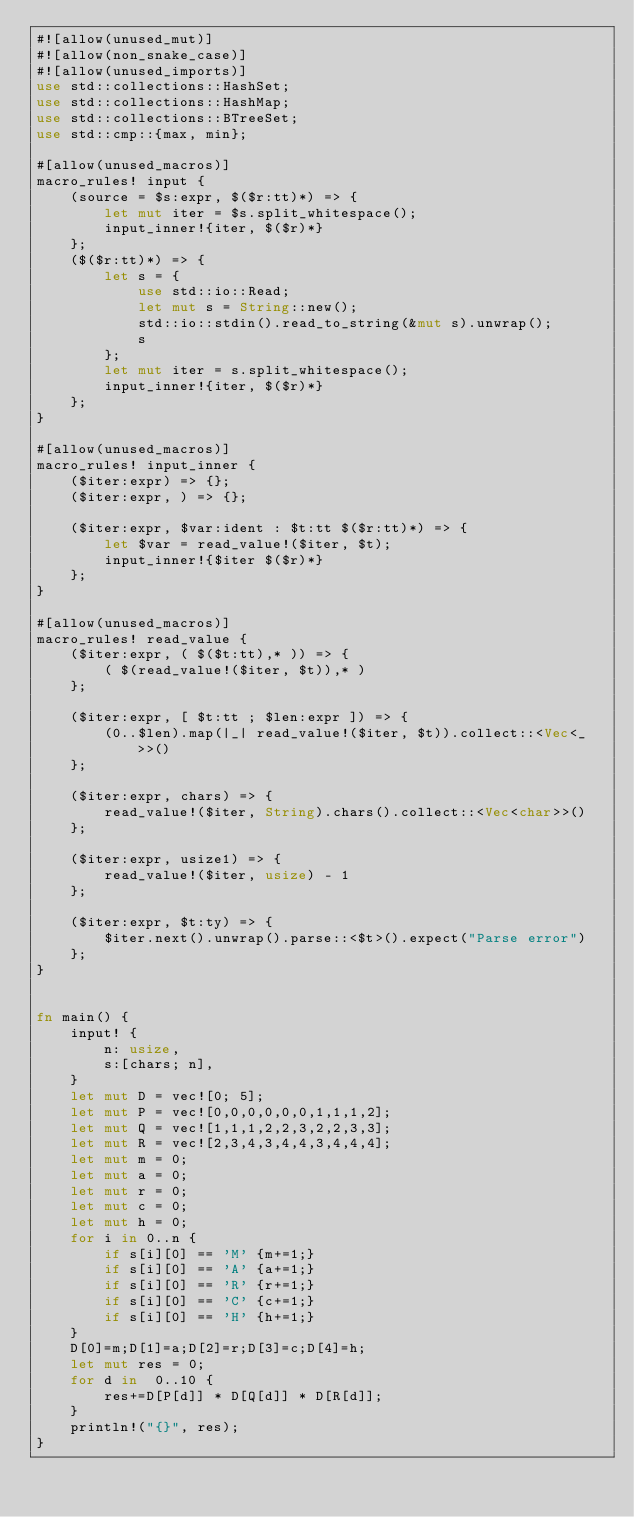<code> <loc_0><loc_0><loc_500><loc_500><_Rust_>#![allow(unused_mut)]
#![allow(non_snake_case)]
#![allow(unused_imports)]
use std::collections::HashSet;
use std::collections::HashMap;
use std::collections::BTreeSet;
use std::cmp::{max, min};

#[allow(unused_macros)]
macro_rules! input {
    (source = $s:expr, $($r:tt)*) => {
        let mut iter = $s.split_whitespace();
        input_inner!{iter, $($r)*}
    };
    ($($r:tt)*) => {
        let s = {
            use std::io::Read;
            let mut s = String::new();
            std::io::stdin().read_to_string(&mut s).unwrap();
            s
        };
        let mut iter = s.split_whitespace();
        input_inner!{iter, $($r)*}
    };
}

#[allow(unused_macros)]
macro_rules! input_inner {
    ($iter:expr) => {};
    ($iter:expr, ) => {};

    ($iter:expr, $var:ident : $t:tt $($r:tt)*) => {
        let $var = read_value!($iter, $t);
        input_inner!{$iter $($r)*}
    };
}

#[allow(unused_macros)]
macro_rules! read_value {
    ($iter:expr, ( $($t:tt),* )) => {
        ( $(read_value!($iter, $t)),* )
    };

    ($iter:expr, [ $t:tt ; $len:expr ]) => {
        (0..$len).map(|_| read_value!($iter, $t)).collect::<Vec<_>>()
    };

    ($iter:expr, chars) => {
        read_value!($iter, String).chars().collect::<Vec<char>>()
    };

    ($iter:expr, usize1) => {
        read_value!($iter, usize) - 1
    };

    ($iter:expr, $t:ty) => {
        $iter.next().unwrap().parse::<$t>().expect("Parse error")
    };
}


fn main() {
    input! {
        n: usize,
        s:[chars; n],
    }
    let mut D = vec![0; 5];
    let mut P = vec![0,0,0,0,0,0,1,1,1,2];
    let mut Q = vec![1,1,1,2,2,3,2,2,3,3];
    let mut R = vec![2,3,4,3,4,4,3,4,4,4];
    let mut m = 0;
    let mut a = 0;
    let mut r = 0;
    let mut c = 0;
    let mut h = 0;
    for i in 0..n {
        if s[i][0] == 'M' {m+=1;}
        if s[i][0] == 'A' {a+=1;}
        if s[i][0] == 'R' {r+=1;}
        if s[i][0] == 'C' {c+=1;}
        if s[i][0] == 'H' {h+=1;}
    }
    D[0]=m;D[1]=a;D[2]=r;D[3]=c;D[4]=h;
    let mut res = 0;
    for d in  0..10 {
        res+=D[P[d]] * D[Q[d]] * D[R[d]];
    }
    println!("{}", res);
}</code> 